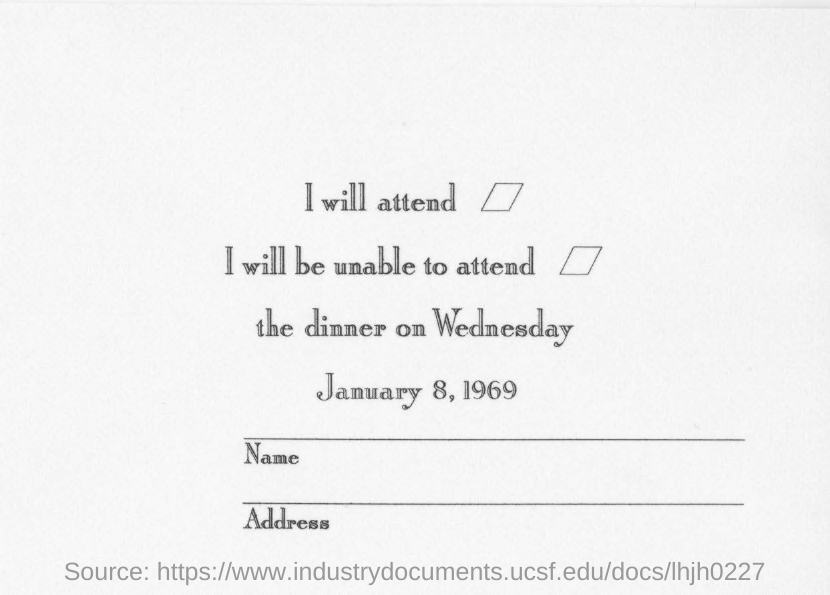Highlight a few significant elements in this photo. The dinner is scheduled to take place on Wednesday. I will be unable to attend the event because the second option mentioned was not suitable for me. It is the first option mentioned that I will attend. The date mentioned is January 8, 1969. 